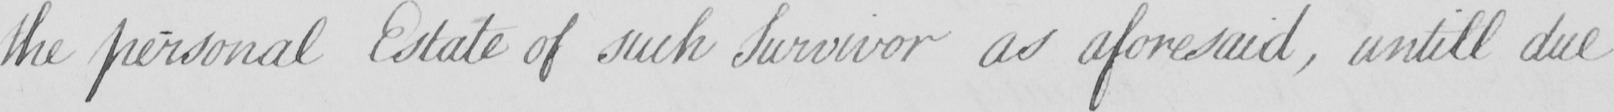What does this handwritten line say? the personal Estate of such Survivor as aforesaid , untill due 